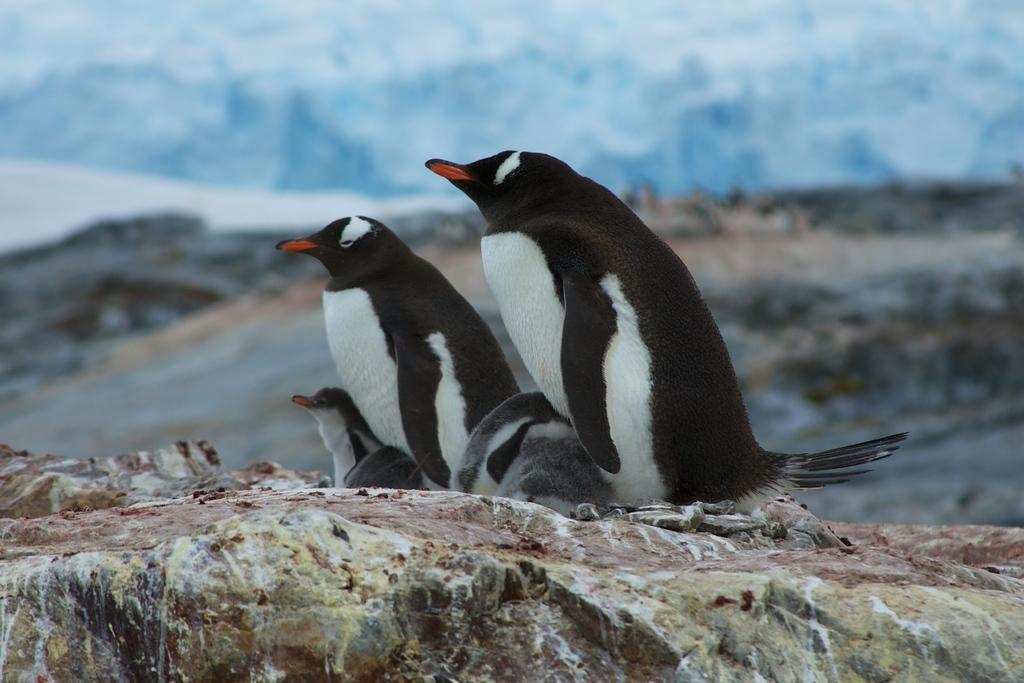What animals are present in the image? There is a group of penguins in the image. What are the penguins standing on? The penguins are standing on a big rock. Can you describe the background of the image? The background of the penguins is blurred. What type of fish can be seen swimming in the background of the image? There are no fish visible in the image; the background is blurred. 